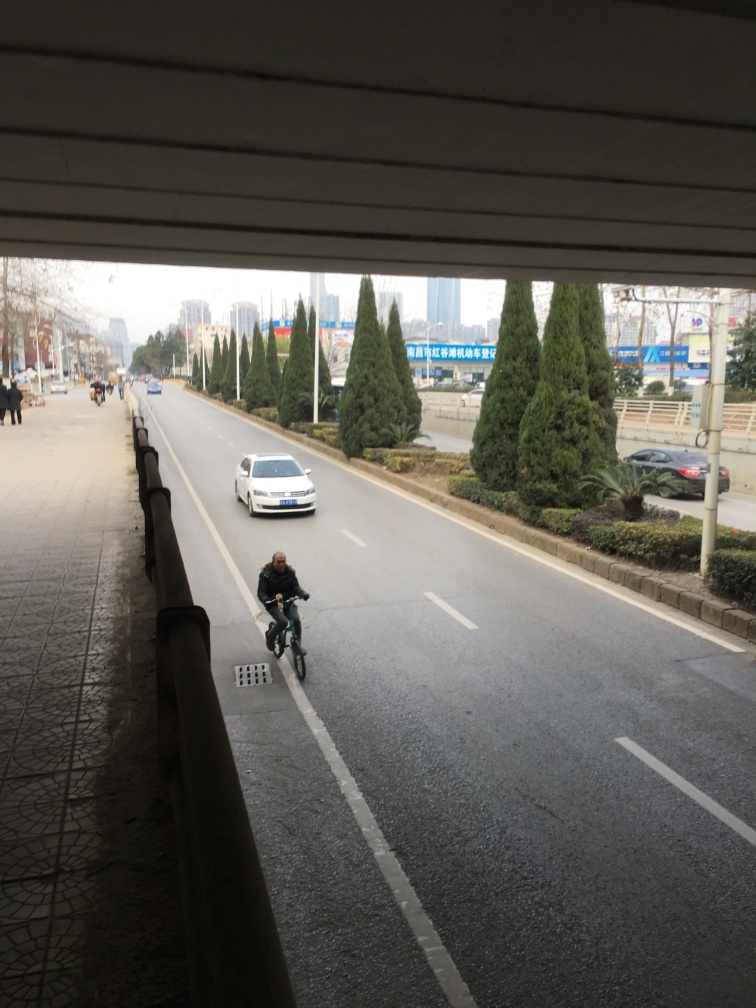What kind of weather does it seem to be in this image? The sky appears overcast, which suggests it could be a cloudy day. There are no indications of rain on the streets, and the visibility is clear. 